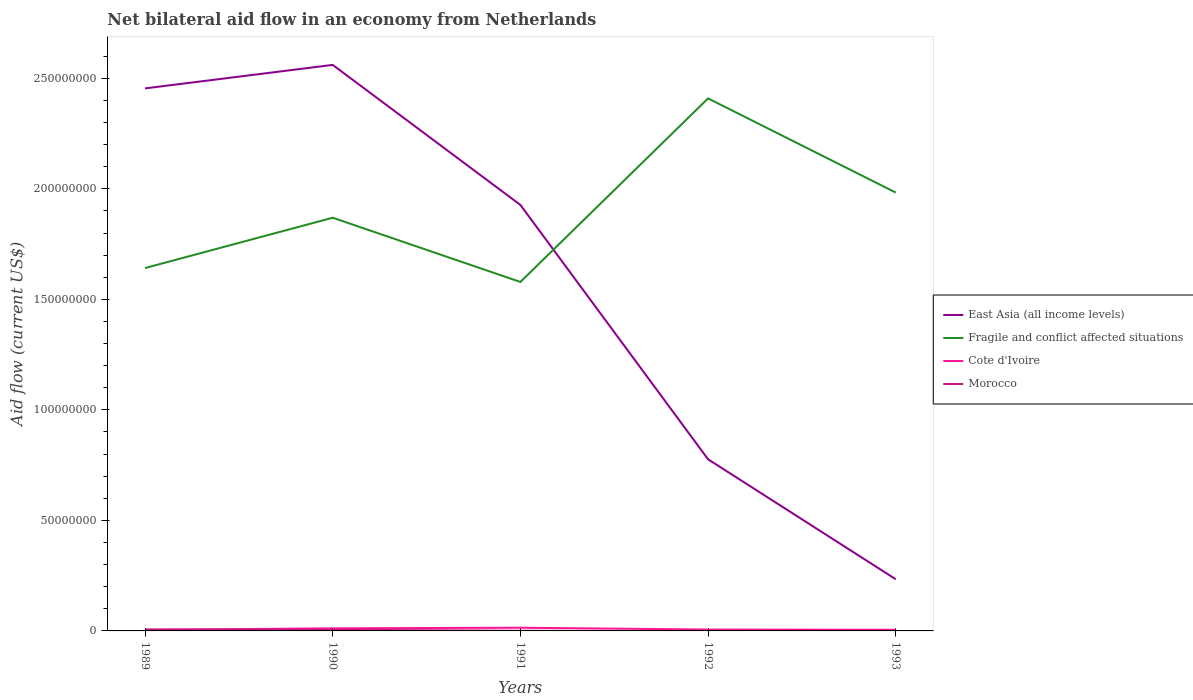How many different coloured lines are there?
Ensure brevity in your answer.  4. Does the line corresponding to Fragile and conflict affected situations intersect with the line corresponding to Morocco?
Make the answer very short. No. Is the number of lines equal to the number of legend labels?
Your answer should be compact. No. Across all years, what is the maximum net bilateral aid flow in East Asia (all income levels)?
Give a very brief answer. 2.34e+07. What is the total net bilateral aid flow in Cote d'Ivoire in the graph?
Make the answer very short. -2.80e+05. What is the difference between the highest and the second highest net bilateral aid flow in East Asia (all income levels)?
Your answer should be compact. 2.33e+08. Is the net bilateral aid flow in Cote d'Ivoire strictly greater than the net bilateral aid flow in Fragile and conflict affected situations over the years?
Your answer should be very brief. Yes. How many lines are there?
Provide a succinct answer. 4. How many years are there in the graph?
Provide a succinct answer. 5. What is the difference between two consecutive major ticks on the Y-axis?
Provide a short and direct response. 5.00e+07. Are the values on the major ticks of Y-axis written in scientific E-notation?
Your response must be concise. No. Where does the legend appear in the graph?
Give a very brief answer. Center right. What is the title of the graph?
Your answer should be compact. Net bilateral aid flow in an economy from Netherlands. Does "India" appear as one of the legend labels in the graph?
Your answer should be very brief. No. What is the label or title of the X-axis?
Your answer should be very brief. Years. What is the Aid flow (current US$) of East Asia (all income levels) in 1989?
Offer a terse response. 2.45e+08. What is the Aid flow (current US$) of Fragile and conflict affected situations in 1989?
Ensure brevity in your answer.  1.64e+08. What is the Aid flow (current US$) in Cote d'Ivoire in 1989?
Your answer should be compact. 4.90e+05. What is the Aid flow (current US$) of East Asia (all income levels) in 1990?
Make the answer very short. 2.56e+08. What is the Aid flow (current US$) of Fragile and conflict affected situations in 1990?
Give a very brief answer. 1.87e+08. What is the Aid flow (current US$) in Cote d'Ivoire in 1990?
Make the answer very short. 1.17e+06. What is the Aid flow (current US$) of Morocco in 1990?
Your answer should be compact. 5.40e+05. What is the Aid flow (current US$) in East Asia (all income levels) in 1991?
Your answer should be compact. 1.93e+08. What is the Aid flow (current US$) in Fragile and conflict affected situations in 1991?
Ensure brevity in your answer.  1.58e+08. What is the Aid flow (current US$) in Cote d'Ivoire in 1991?
Offer a very short reply. 1.45e+06. What is the Aid flow (current US$) in East Asia (all income levels) in 1992?
Provide a short and direct response. 7.76e+07. What is the Aid flow (current US$) of Fragile and conflict affected situations in 1992?
Your answer should be very brief. 2.41e+08. What is the Aid flow (current US$) of Cote d'Ivoire in 1992?
Give a very brief answer. 6.20e+05. What is the Aid flow (current US$) of East Asia (all income levels) in 1993?
Your answer should be very brief. 2.34e+07. What is the Aid flow (current US$) of Fragile and conflict affected situations in 1993?
Ensure brevity in your answer.  1.98e+08. What is the Aid flow (current US$) in Cote d'Ivoire in 1993?
Give a very brief answer. 5.30e+05. What is the Aid flow (current US$) of Morocco in 1993?
Provide a succinct answer. 0. Across all years, what is the maximum Aid flow (current US$) of East Asia (all income levels)?
Give a very brief answer. 2.56e+08. Across all years, what is the maximum Aid flow (current US$) of Fragile and conflict affected situations?
Your answer should be compact. 2.41e+08. Across all years, what is the maximum Aid flow (current US$) in Cote d'Ivoire?
Keep it short and to the point. 1.45e+06. Across all years, what is the minimum Aid flow (current US$) of East Asia (all income levels)?
Offer a very short reply. 2.34e+07. Across all years, what is the minimum Aid flow (current US$) in Fragile and conflict affected situations?
Your response must be concise. 1.58e+08. Across all years, what is the minimum Aid flow (current US$) of Morocco?
Offer a terse response. 0. What is the total Aid flow (current US$) in East Asia (all income levels) in the graph?
Make the answer very short. 7.95e+08. What is the total Aid flow (current US$) in Fragile and conflict affected situations in the graph?
Provide a succinct answer. 9.48e+08. What is the total Aid flow (current US$) in Cote d'Ivoire in the graph?
Give a very brief answer. 4.26e+06. What is the total Aid flow (current US$) of Morocco in the graph?
Offer a very short reply. 1.28e+06. What is the difference between the Aid flow (current US$) in East Asia (all income levels) in 1989 and that in 1990?
Offer a terse response. -1.06e+07. What is the difference between the Aid flow (current US$) in Fragile and conflict affected situations in 1989 and that in 1990?
Keep it short and to the point. -2.28e+07. What is the difference between the Aid flow (current US$) in Cote d'Ivoire in 1989 and that in 1990?
Provide a short and direct response. -6.80e+05. What is the difference between the Aid flow (current US$) in Morocco in 1989 and that in 1990?
Provide a short and direct response. 1.20e+05. What is the difference between the Aid flow (current US$) of East Asia (all income levels) in 1989 and that in 1991?
Offer a very short reply. 5.27e+07. What is the difference between the Aid flow (current US$) in Fragile and conflict affected situations in 1989 and that in 1991?
Your response must be concise. 6.29e+06. What is the difference between the Aid flow (current US$) in Cote d'Ivoire in 1989 and that in 1991?
Ensure brevity in your answer.  -9.60e+05. What is the difference between the Aid flow (current US$) in Morocco in 1989 and that in 1991?
Your answer should be very brief. 5.80e+05. What is the difference between the Aid flow (current US$) in East Asia (all income levels) in 1989 and that in 1992?
Ensure brevity in your answer.  1.68e+08. What is the difference between the Aid flow (current US$) in Fragile and conflict affected situations in 1989 and that in 1992?
Make the answer very short. -7.67e+07. What is the difference between the Aid flow (current US$) of Cote d'Ivoire in 1989 and that in 1992?
Keep it short and to the point. -1.30e+05. What is the difference between the Aid flow (current US$) in East Asia (all income levels) in 1989 and that in 1993?
Provide a succinct answer. 2.22e+08. What is the difference between the Aid flow (current US$) in Fragile and conflict affected situations in 1989 and that in 1993?
Offer a very short reply. -3.42e+07. What is the difference between the Aid flow (current US$) of Cote d'Ivoire in 1989 and that in 1993?
Your response must be concise. -4.00e+04. What is the difference between the Aid flow (current US$) of East Asia (all income levels) in 1990 and that in 1991?
Your answer should be compact. 6.33e+07. What is the difference between the Aid flow (current US$) in Fragile and conflict affected situations in 1990 and that in 1991?
Offer a terse response. 2.90e+07. What is the difference between the Aid flow (current US$) in Cote d'Ivoire in 1990 and that in 1991?
Your answer should be compact. -2.80e+05. What is the difference between the Aid flow (current US$) in Morocco in 1990 and that in 1991?
Your answer should be very brief. 4.60e+05. What is the difference between the Aid flow (current US$) in East Asia (all income levels) in 1990 and that in 1992?
Offer a terse response. 1.78e+08. What is the difference between the Aid flow (current US$) of Fragile and conflict affected situations in 1990 and that in 1992?
Make the answer very short. -5.40e+07. What is the difference between the Aid flow (current US$) in Cote d'Ivoire in 1990 and that in 1992?
Offer a very short reply. 5.50e+05. What is the difference between the Aid flow (current US$) in East Asia (all income levels) in 1990 and that in 1993?
Offer a terse response. 2.33e+08. What is the difference between the Aid flow (current US$) of Fragile and conflict affected situations in 1990 and that in 1993?
Keep it short and to the point. -1.14e+07. What is the difference between the Aid flow (current US$) of Cote d'Ivoire in 1990 and that in 1993?
Provide a succinct answer. 6.40e+05. What is the difference between the Aid flow (current US$) of East Asia (all income levels) in 1991 and that in 1992?
Make the answer very short. 1.15e+08. What is the difference between the Aid flow (current US$) in Fragile and conflict affected situations in 1991 and that in 1992?
Keep it short and to the point. -8.30e+07. What is the difference between the Aid flow (current US$) in Cote d'Ivoire in 1991 and that in 1992?
Provide a succinct answer. 8.30e+05. What is the difference between the Aid flow (current US$) of East Asia (all income levels) in 1991 and that in 1993?
Keep it short and to the point. 1.69e+08. What is the difference between the Aid flow (current US$) of Fragile and conflict affected situations in 1991 and that in 1993?
Give a very brief answer. -4.04e+07. What is the difference between the Aid flow (current US$) in Cote d'Ivoire in 1991 and that in 1993?
Your answer should be very brief. 9.20e+05. What is the difference between the Aid flow (current US$) of East Asia (all income levels) in 1992 and that in 1993?
Make the answer very short. 5.43e+07. What is the difference between the Aid flow (current US$) of Fragile and conflict affected situations in 1992 and that in 1993?
Keep it short and to the point. 4.26e+07. What is the difference between the Aid flow (current US$) of East Asia (all income levels) in 1989 and the Aid flow (current US$) of Fragile and conflict affected situations in 1990?
Make the answer very short. 5.85e+07. What is the difference between the Aid flow (current US$) in East Asia (all income levels) in 1989 and the Aid flow (current US$) in Cote d'Ivoire in 1990?
Give a very brief answer. 2.44e+08. What is the difference between the Aid flow (current US$) of East Asia (all income levels) in 1989 and the Aid flow (current US$) of Morocco in 1990?
Ensure brevity in your answer.  2.45e+08. What is the difference between the Aid flow (current US$) of Fragile and conflict affected situations in 1989 and the Aid flow (current US$) of Cote d'Ivoire in 1990?
Your response must be concise. 1.63e+08. What is the difference between the Aid flow (current US$) in Fragile and conflict affected situations in 1989 and the Aid flow (current US$) in Morocco in 1990?
Offer a terse response. 1.64e+08. What is the difference between the Aid flow (current US$) of East Asia (all income levels) in 1989 and the Aid flow (current US$) of Fragile and conflict affected situations in 1991?
Give a very brief answer. 8.76e+07. What is the difference between the Aid flow (current US$) of East Asia (all income levels) in 1989 and the Aid flow (current US$) of Cote d'Ivoire in 1991?
Ensure brevity in your answer.  2.44e+08. What is the difference between the Aid flow (current US$) of East Asia (all income levels) in 1989 and the Aid flow (current US$) of Morocco in 1991?
Provide a succinct answer. 2.45e+08. What is the difference between the Aid flow (current US$) in Fragile and conflict affected situations in 1989 and the Aid flow (current US$) in Cote d'Ivoire in 1991?
Give a very brief answer. 1.63e+08. What is the difference between the Aid flow (current US$) of Fragile and conflict affected situations in 1989 and the Aid flow (current US$) of Morocco in 1991?
Make the answer very short. 1.64e+08. What is the difference between the Aid flow (current US$) in East Asia (all income levels) in 1989 and the Aid flow (current US$) in Fragile and conflict affected situations in 1992?
Give a very brief answer. 4.53e+06. What is the difference between the Aid flow (current US$) of East Asia (all income levels) in 1989 and the Aid flow (current US$) of Cote d'Ivoire in 1992?
Provide a succinct answer. 2.45e+08. What is the difference between the Aid flow (current US$) in Fragile and conflict affected situations in 1989 and the Aid flow (current US$) in Cote d'Ivoire in 1992?
Offer a very short reply. 1.64e+08. What is the difference between the Aid flow (current US$) of East Asia (all income levels) in 1989 and the Aid flow (current US$) of Fragile and conflict affected situations in 1993?
Provide a succinct answer. 4.71e+07. What is the difference between the Aid flow (current US$) in East Asia (all income levels) in 1989 and the Aid flow (current US$) in Cote d'Ivoire in 1993?
Make the answer very short. 2.45e+08. What is the difference between the Aid flow (current US$) of Fragile and conflict affected situations in 1989 and the Aid flow (current US$) of Cote d'Ivoire in 1993?
Your answer should be compact. 1.64e+08. What is the difference between the Aid flow (current US$) in East Asia (all income levels) in 1990 and the Aid flow (current US$) in Fragile and conflict affected situations in 1991?
Your answer should be compact. 9.82e+07. What is the difference between the Aid flow (current US$) in East Asia (all income levels) in 1990 and the Aid flow (current US$) in Cote d'Ivoire in 1991?
Ensure brevity in your answer.  2.55e+08. What is the difference between the Aid flow (current US$) of East Asia (all income levels) in 1990 and the Aid flow (current US$) of Morocco in 1991?
Offer a very short reply. 2.56e+08. What is the difference between the Aid flow (current US$) in Fragile and conflict affected situations in 1990 and the Aid flow (current US$) in Cote d'Ivoire in 1991?
Make the answer very short. 1.85e+08. What is the difference between the Aid flow (current US$) in Fragile and conflict affected situations in 1990 and the Aid flow (current US$) in Morocco in 1991?
Offer a terse response. 1.87e+08. What is the difference between the Aid flow (current US$) of Cote d'Ivoire in 1990 and the Aid flow (current US$) of Morocco in 1991?
Keep it short and to the point. 1.09e+06. What is the difference between the Aid flow (current US$) in East Asia (all income levels) in 1990 and the Aid flow (current US$) in Fragile and conflict affected situations in 1992?
Provide a short and direct response. 1.52e+07. What is the difference between the Aid flow (current US$) of East Asia (all income levels) in 1990 and the Aid flow (current US$) of Cote d'Ivoire in 1992?
Make the answer very short. 2.55e+08. What is the difference between the Aid flow (current US$) of Fragile and conflict affected situations in 1990 and the Aid flow (current US$) of Cote d'Ivoire in 1992?
Make the answer very short. 1.86e+08. What is the difference between the Aid flow (current US$) in East Asia (all income levels) in 1990 and the Aid flow (current US$) in Fragile and conflict affected situations in 1993?
Give a very brief answer. 5.78e+07. What is the difference between the Aid flow (current US$) in East Asia (all income levels) in 1990 and the Aid flow (current US$) in Cote d'Ivoire in 1993?
Offer a very short reply. 2.56e+08. What is the difference between the Aid flow (current US$) in Fragile and conflict affected situations in 1990 and the Aid flow (current US$) in Cote d'Ivoire in 1993?
Offer a very short reply. 1.86e+08. What is the difference between the Aid flow (current US$) in East Asia (all income levels) in 1991 and the Aid flow (current US$) in Fragile and conflict affected situations in 1992?
Your answer should be compact. -4.82e+07. What is the difference between the Aid flow (current US$) in East Asia (all income levels) in 1991 and the Aid flow (current US$) in Cote d'Ivoire in 1992?
Your answer should be very brief. 1.92e+08. What is the difference between the Aid flow (current US$) of Fragile and conflict affected situations in 1991 and the Aid flow (current US$) of Cote d'Ivoire in 1992?
Your answer should be compact. 1.57e+08. What is the difference between the Aid flow (current US$) of East Asia (all income levels) in 1991 and the Aid flow (current US$) of Fragile and conflict affected situations in 1993?
Your answer should be compact. -5.59e+06. What is the difference between the Aid flow (current US$) of East Asia (all income levels) in 1991 and the Aid flow (current US$) of Cote d'Ivoire in 1993?
Your answer should be very brief. 1.92e+08. What is the difference between the Aid flow (current US$) of Fragile and conflict affected situations in 1991 and the Aid flow (current US$) of Cote d'Ivoire in 1993?
Your answer should be compact. 1.57e+08. What is the difference between the Aid flow (current US$) in East Asia (all income levels) in 1992 and the Aid flow (current US$) in Fragile and conflict affected situations in 1993?
Your answer should be very brief. -1.21e+08. What is the difference between the Aid flow (current US$) in East Asia (all income levels) in 1992 and the Aid flow (current US$) in Cote d'Ivoire in 1993?
Make the answer very short. 7.71e+07. What is the difference between the Aid flow (current US$) of Fragile and conflict affected situations in 1992 and the Aid flow (current US$) of Cote d'Ivoire in 1993?
Your answer should be very brief. 2.40e+08. What is the average Aid flow (current US$) in East Asia (all income levels) per year?
Ensure brevity in your answer.  1.59e+08. What is the average Aid flow (current US$) in Fragile and conflict affected situations per year?
Give a very brief answer. 1.90e+08. What is the average Aid flow (current US$) in Cote d'Ivoire per year?
Ensure brevity in your answer.  8.52e+05. What is the average Aid flow (current US$) of Morocco per year?
Make the answer very short. 2.56e+05. In the year 1989, what is the difference between the Aid flow (current US$) in East Asia (all income levels) and Aid flow (current US$) in Fragile and conflict affected situations?
Offer a terse response. 8.13e+07. In the year 1989, what is the difference between the Aid flow (current US$) in East Asia (all income levels) and Aid flow (current US$) in Cote d'Ivoire?
Offer a very short reply. 2.45e+08. In the year 1989, what is the difference between the Aid flow (current US$) of East Asia (all income levels) and Aid flow (current US$) of Morocco?
Offer a very short reply. 2.45e+08. In the year 1989, what is the difference between the Aid flow (current US$) of Fragile and conflict affected situations and Aid flow (current US$) of Cote d'Ivoire?
Offer a terse response. 1.64e+08. In the year 1989, what is the difference between the Aid flow (current US$) in Fragile and conflict affected situations and Aid flow (current US$) in Morocco?
Your answer should be compact. 1.64e+08. In the year 1989, what is the difference between the Aid flow (current US$) in Cote d'Ivoire and Aid flow (current US$) in Morocco?
Provide a succinct answer. -1.70e+05. In the year 1990, what is the difference between the Aid flow (current US$) of East Asia (all income levels) and Aid flow (current US$) of Fragile and conflict affected situations?
Offer a terse response. 6.91e+07. In the year 1990, what is the difference between the Aid flow (current US$) in East Asia (all income levels) and Aid flow (current US$) in Cote d'Ivoire?
Your answer should be very brief. 2.55e+08. In the year 1990, what is the difference between the Aid flow (current US$) of East Asia (all income levels) and Aid flow (current US$) of Morocco?
Keep it short and to the point. 2.56e+08. In the year 1990, what is the difference between the Aid flow (current US$) of Fragile and conflict affected situations and Aid flow (current US$) of Cote d'Ivoire?
Make the answer very short. 1.86e+08. In the year 1990, what is the difference between the Aid flow (current US$) of Fragile and conflict affected situations and Aid flow (current US$) of Morocco?
Offer a very short reply. 1.86e+08. In the year 1990, what is the difference between the Aid flow (current US$) of Cote d'Ivoire and Aid flow (current US$) of Morocco?
Provide a succinct answer. 6.30e+05. In the year 1991, what is the difference between the Aid flow (current US$) in East Asia (all income levels) and Aid flow (current US$) in Fragile and conflict affected situations?
Ensure brevity in your answer.  3.48e+07. In the year 1991, what is the difference between the Aid flow (current US$) in East Asia (all income levels) and Aid flow (current US$) in Cote d'Ivoire?
Keep it short and to the point. 1.91e+08. In the year 1991, what is the difference between the Aid flow (current US$) of East Asia (all income levels) and Aid flow (current US$) of Morocco?
Ensure brevity in your answer.  1.93e+08. In the year 1991, what is the difference between the Aid flow (current US$) in Fragile and conflict affected situations and Aid flow (current US$) in Cote d'Ivoire?
Provide a succinct answer. 1.56e+08. In the year 1991, what is the difference between the Aid flow (current US$) of Fragile and conflict affected situations and Aid flow (current US$) of Morocco?
Provide a short and direct response. 1.58e+08. In the year 1991, what is the difference between the Aid flow (current US$) of Cote d'Ivoire and Aid flow (current US$) of Morocco?
Offer a terse response. 1.37e+06. In the year 1992, what is the difference between the Aid flow (current US$) in East Asia (all income levels) and Aid flow (current US$) in Fragile and conflict affected situations?
Give a very brief answer. -1.63e+08. In the year 1992, what is the difference between the Aid flow (current US$) of East Asia (all income levels) and Aid flow (current US$) of Cote d'Ivoire?
Provide a succinct answer. 7.70e+07. In the year 1992, what is the difference between the Aid flow (current US$) in Fragile and conflict affected situations and Aid flow (current US$) in Cote d'Ivoire?
Keep it short and to the point. 2.40e+08. In the year 1993, what is the difference between the Aid flow (current US$) in East Asia (all income levels) and Aid flow (current US$) in Fragile and conflict affected situations?
Provide a succinct answer. -1.75e+08. In the year 1993, what is the difference between the Aid flow (current US$) in East Asia (all income levels) and Aid flow (current US$) in Cote d'Ivoire?
Offer a very short reply. 2.28e+07. In the year 1993, what is the difference between the Aid flow (current US$) in Fragile and conflict affected situations and Aid flow (current US$) in Cote d'Ivoire?
Provide a short and direct response. 1.98e+08. What is the ratio of the Aid flow (current US$) of East Asia (all income levels) in 1989 to that in 1990?
Ensure brevity in your answer.  0.96. What is the ratio of the Aid flow (current US$) in Fragile and conflict affected situations in 1989 to that in 1990?
Keep it short and to the point. 0.88. What is the ratio of the Aid flow (current US$) in Cote d'Ivoire in 1989 to that in 1990?
Your answer should be very brief. 0.42. What is the ratio of the Aid flow (current US$) of Morocco in 1989 to that in 1990?
Give a very brief answer. 1.22. What is the ratio of the Aid flow (current US$) of East Asia (all income levels) in 1989 to that in 1991?
Give a very brief answer. 1.27. What is the ratio of the Aid flow (current US$) in Fragile and conflict affected situations in 1989 to that in 1991?
Ensure brevity in your answer.  1.04. What is the ratio of the Aid flow (current US$) in Cote d'Ivoire in 1989 to that in 1991?
Your response must be concise. 0.34. What is the ratio of the Aid flow (current US$) of Morocco in 1989 to that in 1991?
Offer a very short reply. 8.25. What is the ratio of the Aid flow (current US$) of East Asia (all income levels) in 1989 to that in 1992?
Your response must be concise. 3.16. What is the ratio of the Aid flow (current US$) of Fragile and conflict affected situations in 1989 to that in 1992?
Provide a short and direct response. 0.68. What is the ratio of the Aid flow (current US$) in Cote d'Ivoire in 1989 to that in 1992?
Give a very brief answer. 0.79. What is the ratio of the Aid flow (current US$) of East Asia (all income levels) in 1989 to that in 1993?
Offer a terse response. 10.5. What is the ratio of the Aid flow (current US$) in Fragile and conflict affected situations in 1989 to that in 1993?
Your answer should be very brief. 0.83. What is the ratio of the Aid flow (current US$) in Cote d'Ivoire in 1989 to that in 1993?
Keep it short and to the point. 0.92. What is the ratio of the Aid flow (current US$) in East Asia (all income levels) in 1990 to that in 1991?
Offer a very short reply. 1.33. What is the ratio of the Aid flow (current US$) of Fragile and conflict affected situations in 1990 to that in 1991?
Provide a succinct answer. 1.18. What is the ratio of the Aid flow (current US$) of Cote d'Ivoire in 1990 to that in 1991?
Give a very brief answer. 0.81. What is the ratio of the Aid flow (current US$) in Morocco in 1990 to that in 1991?
Keep it short and to the point. 6.75. What is the ratio of the Aid flow (current US$) of East Asia (all income levels) in 1990 to that in 1992?
Ensure brevity in your answer.  3.3. What is the ratio of the Aid flow (current US$) of Fragile and conflict affected situations in 1990 to that in 1992?
Your answer should be compact. 0.78. What is the ratio of the Aid flow (current US$) of Cote d'Ivoire in 1990 to that in 1992?
Provide a succinct answer. 1.89. What is the ratio of the Aid flow (current US$) of East Asia (all income levels) in 1990 to that in 1993?
Provide a succinct answer. 10.95. What is the ratio of the Aid flow (current US$) in Fragile and conflict affected situations in 1990 to that in 1993?
Offer a very short reply. 0.94. What is the ratio of the Aid flow (current US$) of Cote d'Ivoire in 1990 to that in 1993?
Make the answer very short. 2.21. What is the ratio of the Aid flow (current US$) in East Asia (all income levels) in 1991 to that in 1992?
Your answer should be very brief. 2.48. What is the ratio of the Aid flow (current US$) in Fragile and conflict affected situations in 1991 to that in 1992?
Offer a very short reply. 0.66. What is the ratio of the Aid flow (current US$) of Cote d'Ivoire in 1991 to that in 1992?
Provide a short and direct response. 2.34. What is the ratio of the Aid flow (current US$) of East Asia (all income levels) in 1991 to that in 1993?
Provide a succinct answer. 8.24. What is the ratio of the Aid flow (current US$) of Fragile and conflict affected situations in 1991 to that in 1993?
Give a very brief answer. 0.8. What is the ratio of the Aid flow (current US$) in Cote d'Ivoire in 1991 to that in 1993?
Ensure brevity in your answer.  2.74. What is the ratio of the Aid flow (current US$) in East Asia (all income levels) in 1992 to that in 1993?
Ensure brevity in your answer.  3.32. What is the ratio of the Aid flow (current US$) in Fragile and conflict affected situations in 1992 to that in 1993?
Make the answer very short. 1.21. What is the ratio of the Aid flow (current US$) in Cote d'Ivoire in 1992 to that in 1993?
Give a very brief answer. 1.17. What is the difference between the highest and the second highest Aid flow (current US$) of East Asia (all income levels)?
Provide a succinct answer. 1.06e+07. What is the difference between the highest and the second highest Aid flow (current US$) of Fragile and conflict affected situations?
Your answer should be compact. 4.26e+07. What is the difference between the highest and the lowest Aid flow (current US$) in East Asia (all income levels)?
Give a very brief answer. 2.33e+08. What is the difference between the highest and the lowest Aid flow (current US$) of Fragile and conflict affected situations?
Provide a short and direct response. 8.30e+07. What is the difference between the highest and the lowest Aid flow (current US$) of Cote d'Ivoire?
Your answer should be very brief. 9.60e+05. What is the difference between the highest and the lowest Aid flow (current US$) in Morocco?
Make the answer very short. 6.60e+05. 